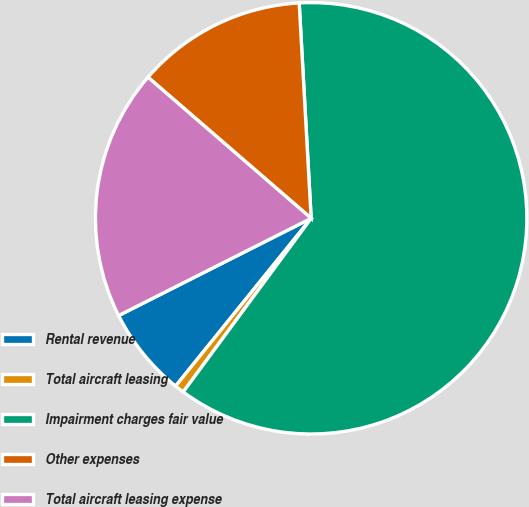Convert chart. <chart><loc_0><loc_0><loc_500><loc_500><pie_chart><fcel>Rental revenue<fcel>Total aircraft leasing<fcel>Impairment charges fair value<fcel>Other expenses<fcel>Total aircraft leasing expense<nl><fcel>6.74%<fcel>0.71%<fcel>60.99%<fcel>12.77%<fcel>18.79%<nl></chart> 